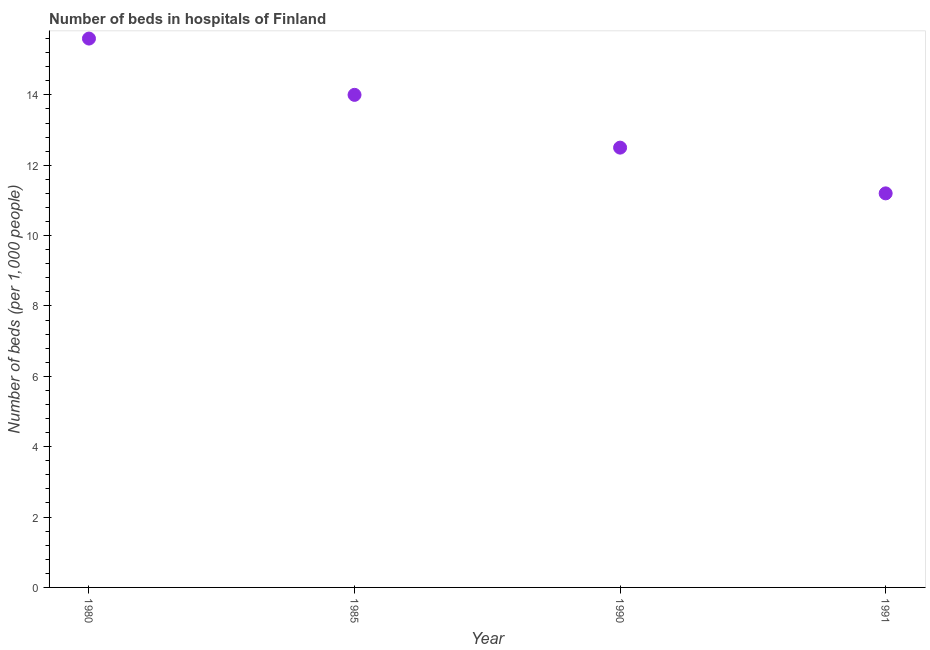Across all years, what is the maximum number of hospital beds?
Give a very brief answer. 15.6. Across all years, what is the minimum number of hospital beds?
Your answer should be compact. 11.2. What is the sum of the number of hospital beds?
Give a very brief answer. 53.3. What is the difference between the number of hospital beds in 1990 and 1991?
Your answer should be compact. 1.3. What is the average number of hospital beds per year?
Your answer should be compact. 13.33. What is the median number of hospital beds?
Provide a short and direct response. 13.25. What is the ratio of the number of hospital beds in 1980 to that in 1990?
Offer a very short reply. 1.25. Is the number of hospital beds in 1980 less than that in 1990?
Make the answer very short. No. What is the difference between the highest and the second highest number of hospital beds?
Keep it short and to the point. 1.6. What is the difference between the highest and the lowest number of hospital beds?
Provide a short and direct response. 4.4. How many dotlines are there?
Your answer should be very brief. 1. How many years are there in the graph?
Give a very brief answer. 4. Are the values on the major ticks of Y-axis written in scientific E-notation?
Give a very brief answer. No. Does the graph contain any zero values?
Your answer should be very brief. No. Does the graph contain grids?
Ensure brevity in your answer.  No. What is the title of the graph?
Ensure brevity in your answer.  Number of beds in hospitals of Finland. What is the label or title of the X-axis?
Provide a short and direct response. Year. What is the label or title of the Y-axis?
Keep it short and to the point. Number of beds (per 1,0 people). What is the Number of beds (per 1,000 people) in 1980?
Offer a very short reply. 15.6. What is the Number of beds (per 1,000 people) in 1991?
Keep it short and to the point. 11.2. What is the difference between the Number of beds (per 1,000 people) in 1980 and 1985?
Give a very brief answer. 1.6. What is the difference between the Number of beds (per 1,000 people) in 1980 and 1990?
Offer a terse response. 3.1. What is the difference between the Number of beds (per 1,000 people) in 1980 and 1991?
Your answer should be compact. 4.4. What is the difference between the Number of beds (per 1,000 people) in 1985 and 1990?
Offer a terse response. 1.5. What is the ratio of the Number of beds (per 1,000 people) in 1980 to that in 1985?
Offer a very short reply. 1.11. What is the ratio of the Number of beds (per 1,000 people) in 1980 to that in 1990?
Offer a terse response. 1.25. What is the ratio of the Number of beds (per 1,000 people) in 1980 to that in 1991?
Ensure brevity in your answer.  1.39. What is the ratio of the Number of beds (per 1,000 people) in 1985 to that in 1990?
Your response must be concise. 1.12. What is the ratio of the Number of beds (per 1,000 people) in 1985 to that in 1991?
Keep it short and to the point. 1.25. What is the ratio of the Number of beds (per 1,000 people) in 1990 to that in 1991?
Offer a terse response. 1.12. 